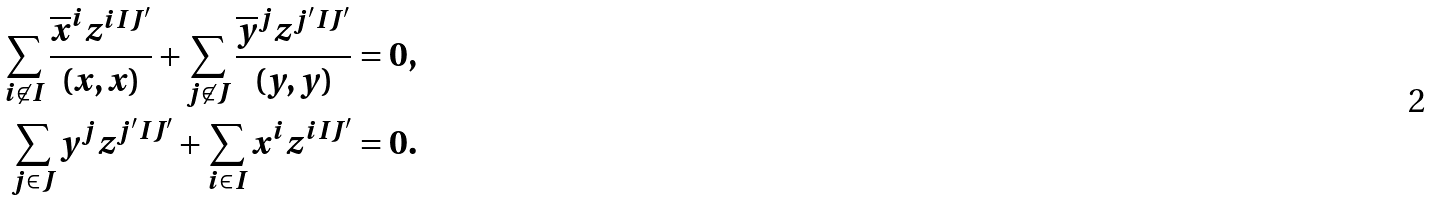<formula> <loc_0><loc_0><loc_500><loc_500>\sum _ { i \not \in I } \frac { \overline { x } ^ { i } z ^ { i I J ^ { \prime } } } { ( x , x ) } + \sum _ { j \not \in J } \frac { \overline { y } ^ { j } z ^ { j ^ { \prime } I J ^ { \prime } } } { ( y , y ) } & = 0 , \\ \sum _ { j \in J } y ^ { j } z ^ { j ^ { \prime } I J ^ { \prime } } + \sum _ { i \in I } x ^ { i } z ^ { i I J ^ { \prime } } & = 0 .</formula> 